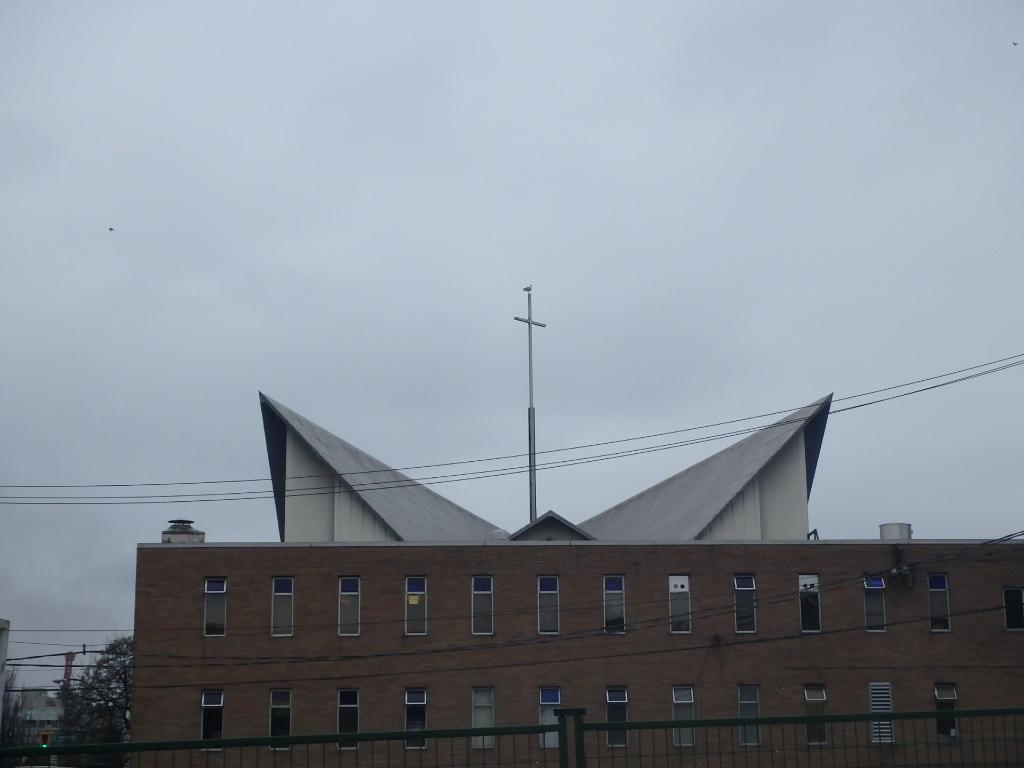What type of structure is present in the image? There is a building in the image. What other objects can be seen in the image? Poles, a grill, electric cables, and windows are visible in the image. What is the background of the image like? Trees and the sky are visible in the background of the image. How many cribs are present in the image? There are no cribs present in the image. What type of cork can be seen in the image? There is no cork present in the image. 